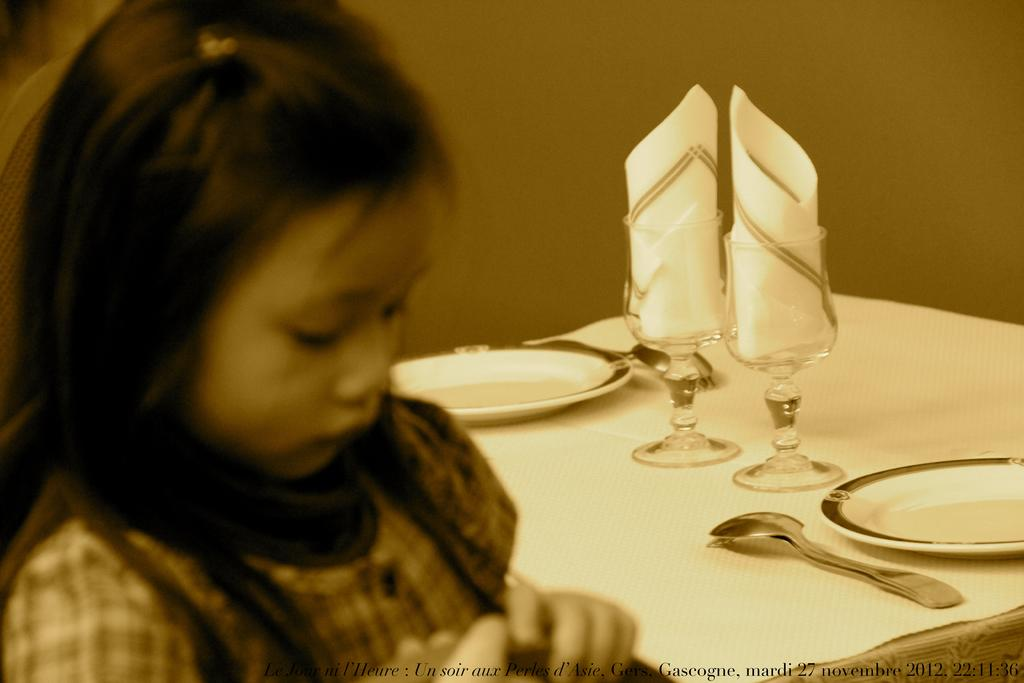What is the woman doing in the image? The woman is sitting on a chair in the image. What is located near the woman? There is a table in the image. What items can be seen on the table? There are glasses, plates, and a spoon on the table. Can you tell me how many needles are on the table in the image? There are no needles present on the table in the image. What type of help is the woman providing in the image? The image does not show the woman providing any help, as she is simply sitting on a chair. 